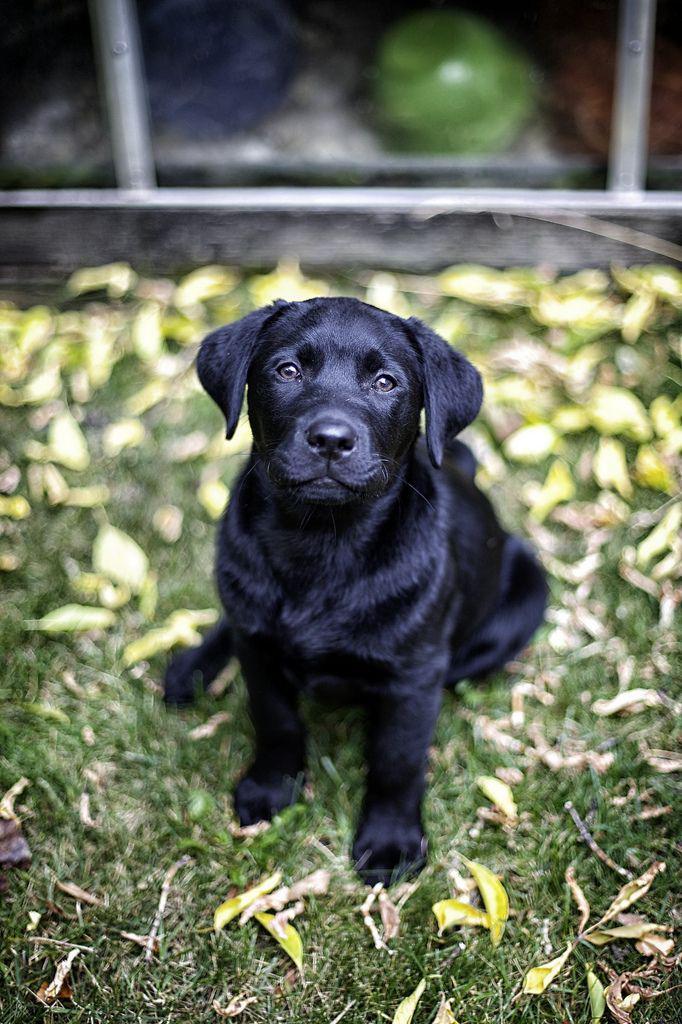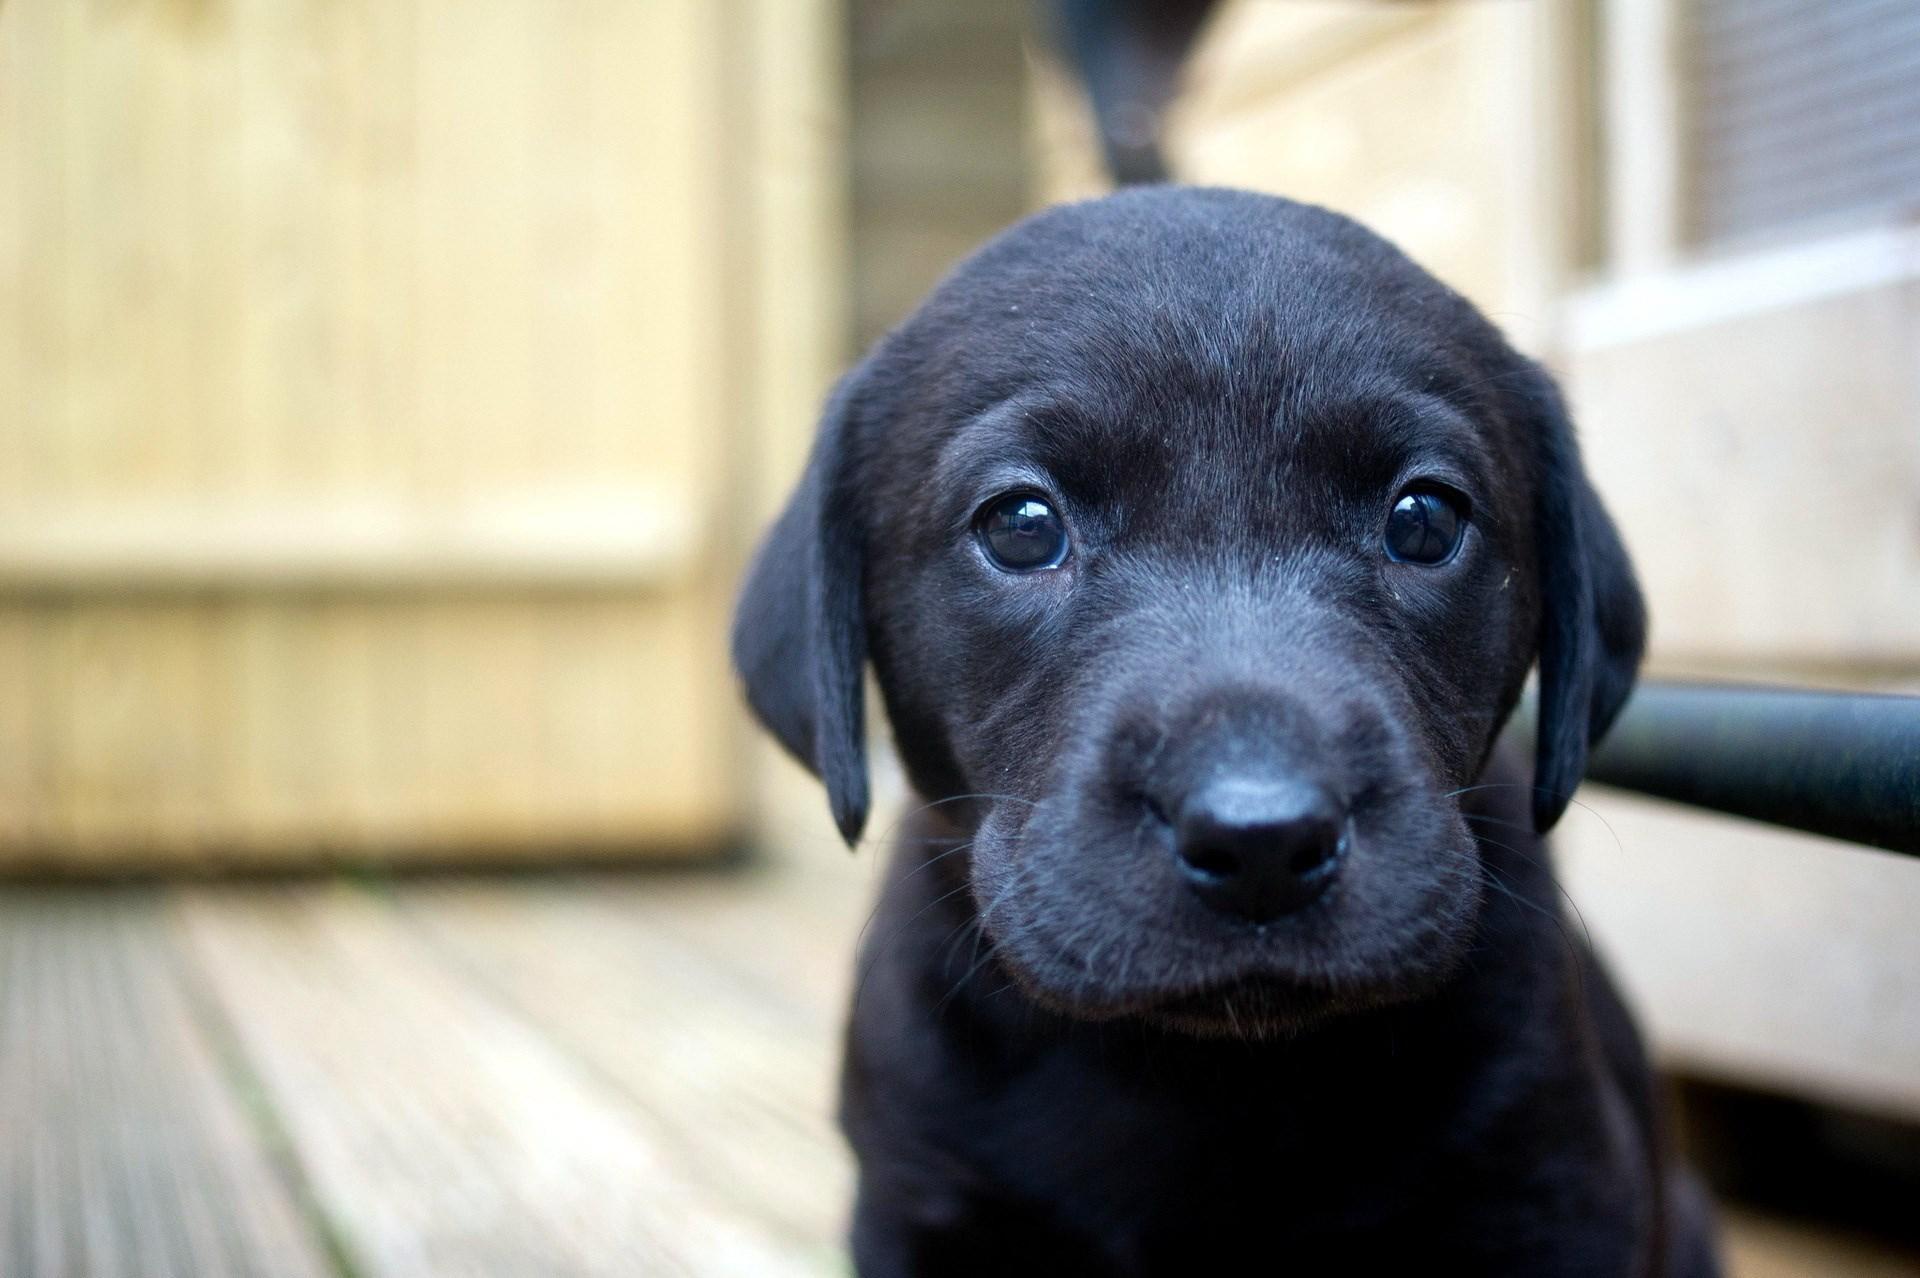The first image is the image on the left, the second image is the image on the right. Assess this claim about the two images: "Each image shows one forward-facing young dog, and the dogs in the left and right images have dark fur color.". Correct or not? Answer yes or no. Yes. The first image is the image on the left, the second image is the image on the right. Given the left and right images, does the statement "there are two black puppies in the image pair" hold true? Answer yes or no. Yes. 